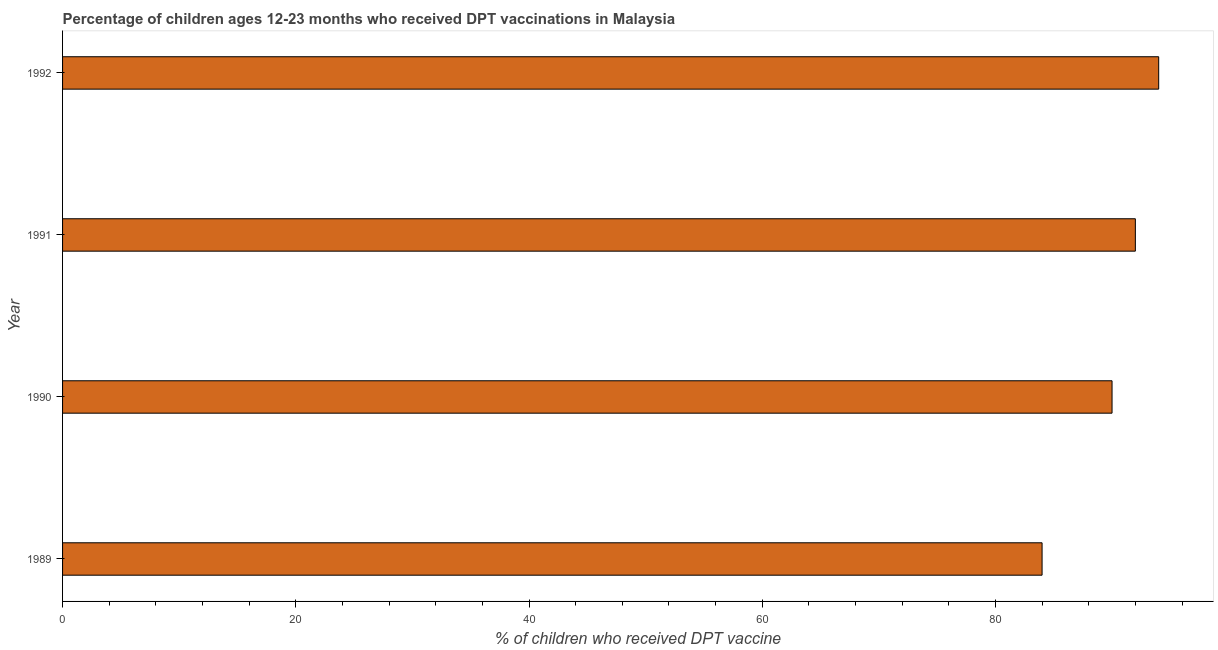Does the graph contain grids?
Make the answer very short. No. What is the title of the graph?
Make the answer very short. Percentage of children ages 12-23 months who received DPT vaccinations in Malaysia. What is the label or title of the X-axis?
Give a very brief answer. % of children who received DPT vaccine. What is the percentage of children who received dpt vaccine in 1990?
Keep it short and to the point. 90. Across all years, what is the maximum percentage of children who received dpt vaccine?
Make the answer very short. 94. In which year was the percentage of children who received dpt vaccine maximum?
Offer a terse response. 1992. What is the sum of the percentage of children who received dpt vaccine?
Offer a terse response. 360. What is the difference between the percentage of children who received dpt vaccine in 1989 and 1992?
Offer a terse response. -10. What is the median percentage of children who received dpt vaccine?
Ensure brevity in your answer.  91. In how many years, is the percentage of children who received dpt vaccine greater than 64 %?
Your response must be concise. 4. Is the percentage of children who received dpt vaccine in 1991 less than that in 1992?
Your answer should be very brief. Yes. What is the difference between the highest and the second highest percentage of children who received dpt vaccine?
Keep it short and to the point. 2. Is the sum of the percentage of children who received dpt vaccine in 1991 and 1992 greater than the maximum percentage of children who received dpt vaccine across all years?
Ensure brevity in your answer.  Yes. In how many years, is the percentage of children who received dpt vaccine greater than the average percentage of children who received dpt vaccine taken over all years?
Provide a succinct answer. 2. How many bars are there?
Provide a succinct answer. 4. Are all the bars in the graph horizontal?
Make the answer very short. Yes. What is the difference between two consecutive major ticks on the X-axis?
Offer a terse response. 20. What is the % of children who received DPT vaccine of 1989?
Ensure brevity in your answer.  84. What is the % of children who received DPT vaccine in 1991?
Your answer should be very brief. 92. What is the % of children who received DPT vaccine of 1992?
Provide a short and direct response. 94. What is the difference between the % of children who received DPT vaccine in 1989 and 1991?
Your answer should be compact. -8. What is the difference between the % of children who received DPT vaccine in 1989 and 1992?
Give a very brief answer. -10. What is the difference between the % of children who received DPT vaccine in 1990 and 1992?
Your answer should be compact. -4. What is the ratio of the % of children who received DPT vaccine in 1989 to that in 1990?
Make the answer very short. 0.93. What is the ratio of the % of children who received DPT vaccine in 1989 to that in 1991?
Keep it short and to the point. 0.91. What is the ratio of the % of children who received DPT vaccine in 1989 to that in 1992?
Your response must be concise. 0.89. What is the ratio of the % of children who received DPT vaccine in 1990 to that in 1991?
Your answer should be compact. 0.98. What is the ratio of the % of children who received DPT vaccine in 1990 to that in 1992?
Provide a short and direct response. 0.96. 